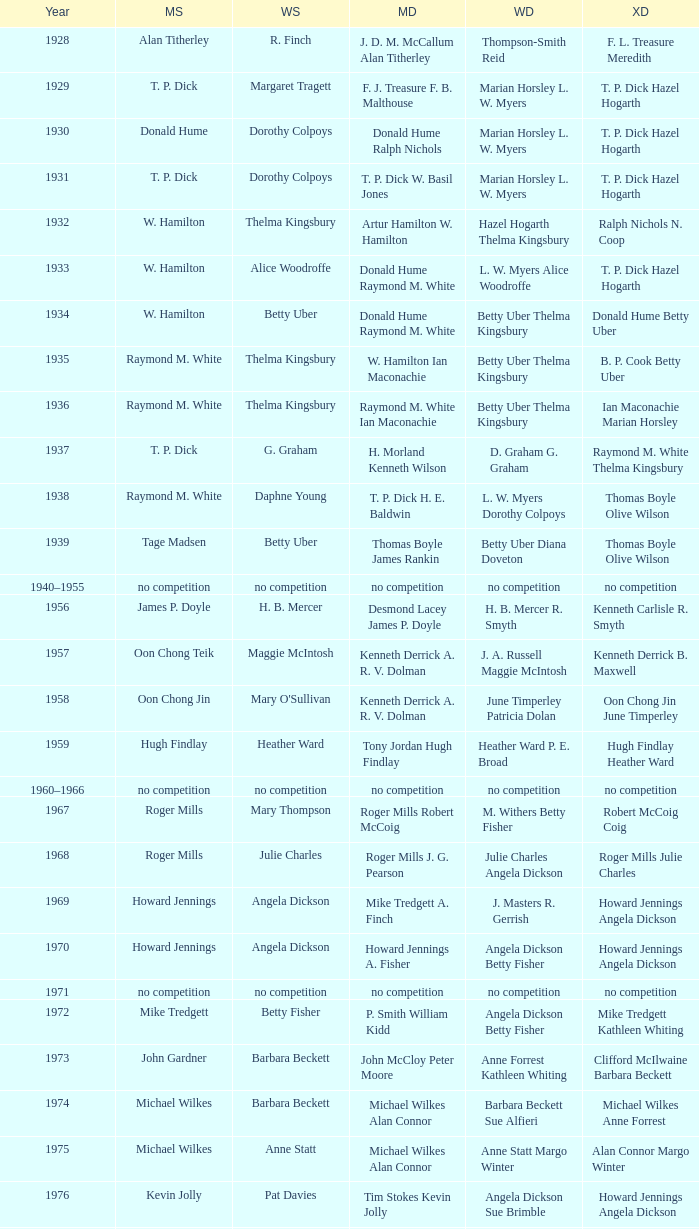Who emerged victorious in the men's singles during the year ian maconachie marian horsley captured the mixed doubles championship? Raymond M. White. 